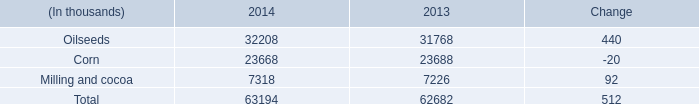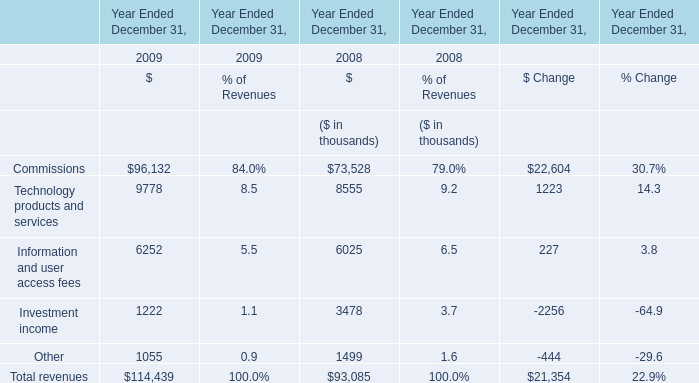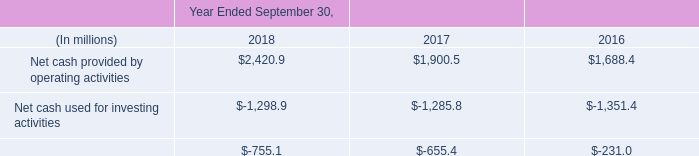as of september 30 , 2018 , what was the percent of the total debt that was current . 
Computations: (740.7 / 6415.2)
Answer: 0.11546. 